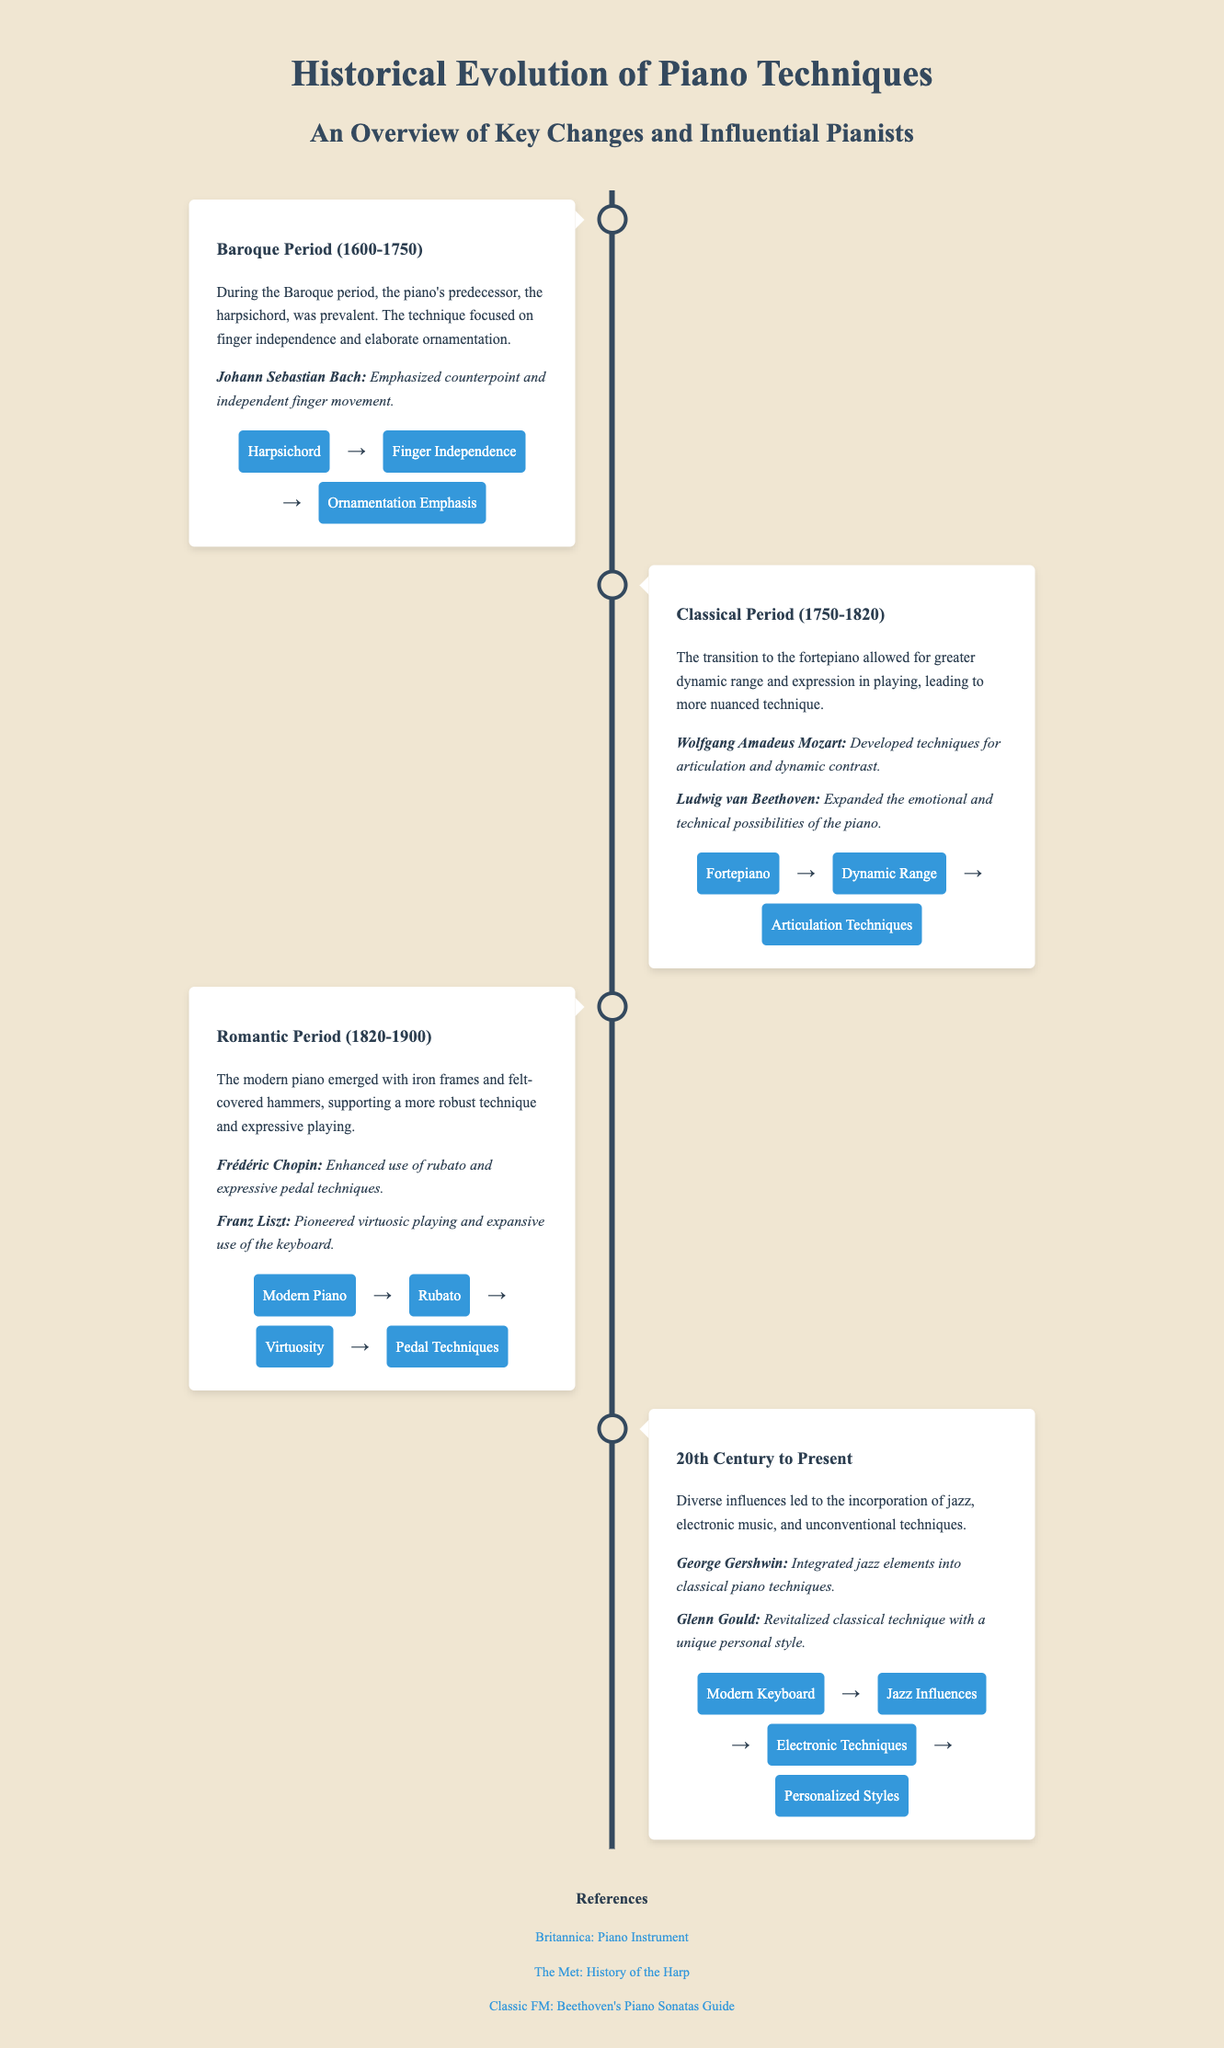What period did Johann Sebastian Bach influence? Johann Sebastian Bach is associated with the Baroque period in the document.
Answer: Baroque Period Which pianist is known for enhancing the use of rubato? The document states that Frédéric Chopin is known for enhancing the use of rubato.
Answer: Frédéric Chopin What instrument preceded the piano during the Baroque period? The document mentions that the harpsichord was prevalent before the piano.
Answer: Harpsichord During which period was the fortepiano introduced? The fortepiano was introduced during the Classical Period according to the timeline in the document.
Answer: Classical Period What impact did George Gershwin have on piano techniques? George Gershwin is noted for integrating jazz elements into classical piano techniques.
Answer: Jazz elements Name a technique pioneered by Franz Liszt. The document highlights that Franz Liszt pioneered virtuosic playing.
Answer: Virtuosic playing What type of piano emerged during the Romantic period? The document states that the modern piano emerged during the Romantic period.
Answer: Modern Piano How did Glenn Gould contribute to piano techniques? Glenn Gould is noted for revitalizing classical technique with a unique personal style.
Answer: Unique personal style 